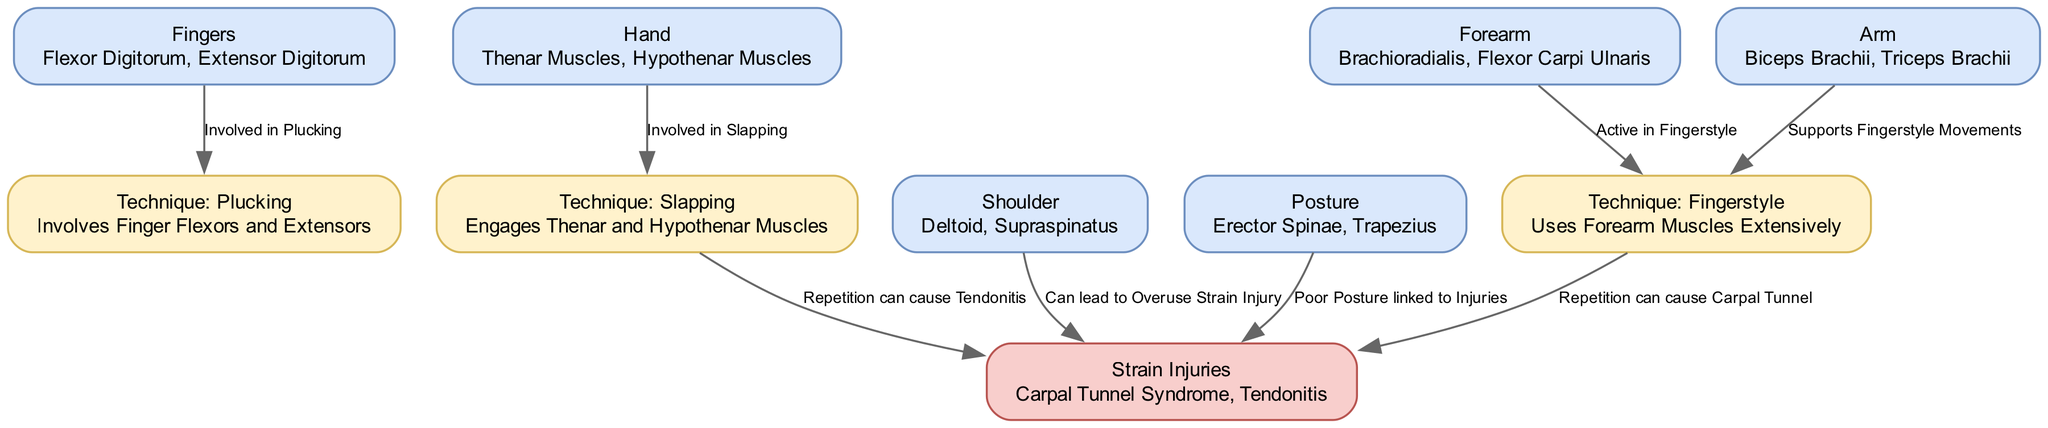What are the strain injuries listed in the diagram? The diagram specifically highlights two strain injuries: Carpal Tunnel Syndrome and Tendonitis. These are mentioned under the "Strain Injuries" node.
Answer: Carpal Tunnel Syndrome, Tendonitis Which technique involves the Fingers muscle group? The "Plucking" technique involves the Fingers muscle group. The edge connecting the "Fingers" node to the "Technique: Plucking" node indicates this relationship.
Answer: Plucking How many muscle groups are directly involved in the Fingerstyle technique? The Fingerstyle technique engages two muscle groups: Forearm and Arm. Both are connected to the "Technique: Fingerstyle" node by edges, indicating they are involved in this technique.
Answer: 2 Which muscle group is associated with poor posture leading to injuries? The "Posture" muscle group, which includes Erector Spinae and Trapezius, is associated with poor posture that can lead to strain injuries. The edge connects this node to the "Strain Injuries" node.
Answer: Posture What muscle group does the Slapping technique engage? The Slapping technique specifically engages the Thenar and Hypothenar Muscles. This is indicated by the edge connecting the "Hand" node to the "Technique: Slapping" node.
Answer: Hand What are the two techniques that can cause strain injuries due to repetition? The two techniques that can cause strain injuries due to repetition are Slapping and Fingerstyle. The diagram shows edges from these technique nodes to the "Strain Injuries" node, indicating their relationship to overuse injuries.
Answer: Slapping, Fingerstyle 